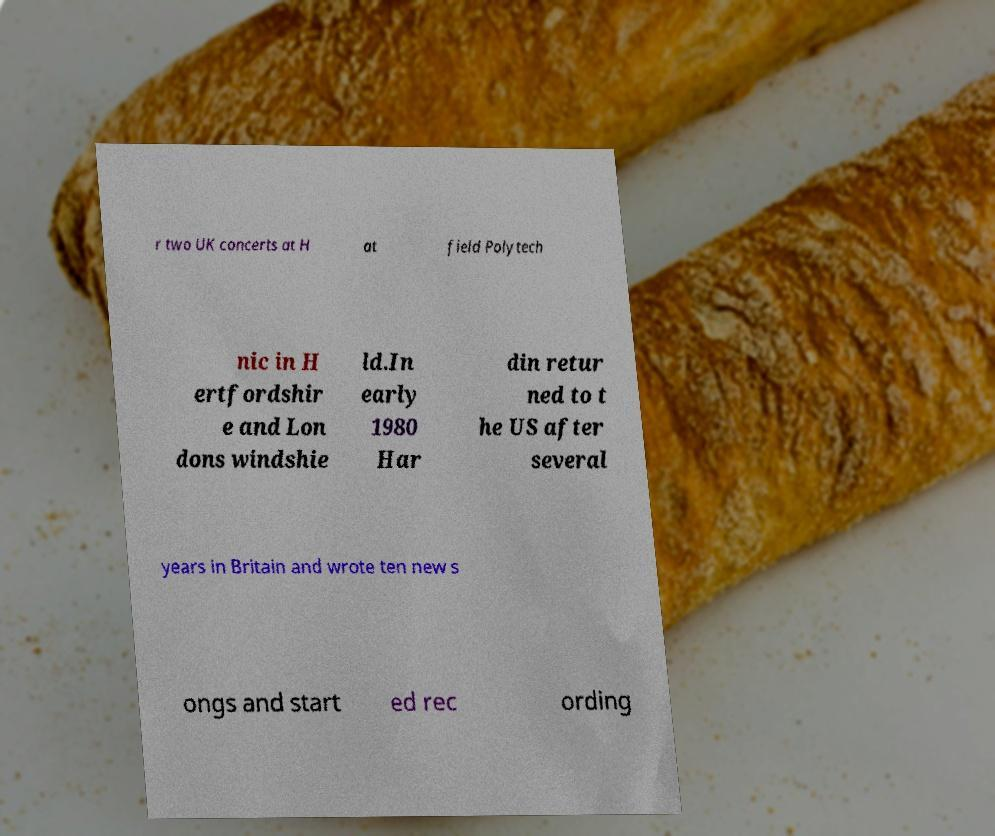What messages or text are displayed in this image? I need them in a readable, typed format. r two UK concerts at H at field Polytech nic in H ertfordshir e and Lon dons windshie ld.In early 1980 Har din retur ned to t he US after several years in Britain and wrote ten new s ongs and start ed rec ording 